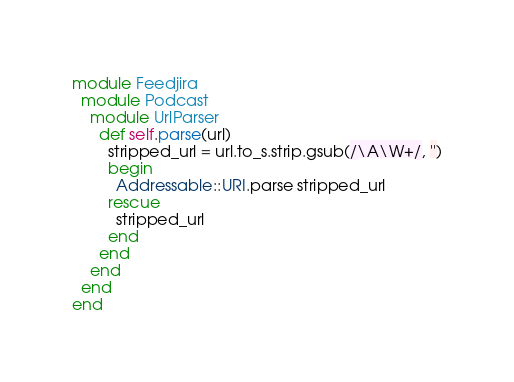<code> <loc_0><loc_0><loc_500><loc_500><_Ruby_>module Feedjira
  module Podcast
    module UrlParser
      def self.parse(url)
        stripped_url = url.to_s.strip.gsub(/\A\W+/, '')
        begin
          Addressable::URI.parse stripped_url
        rescue
          stripped_url
        end
      end
    end
  end
end</code> 